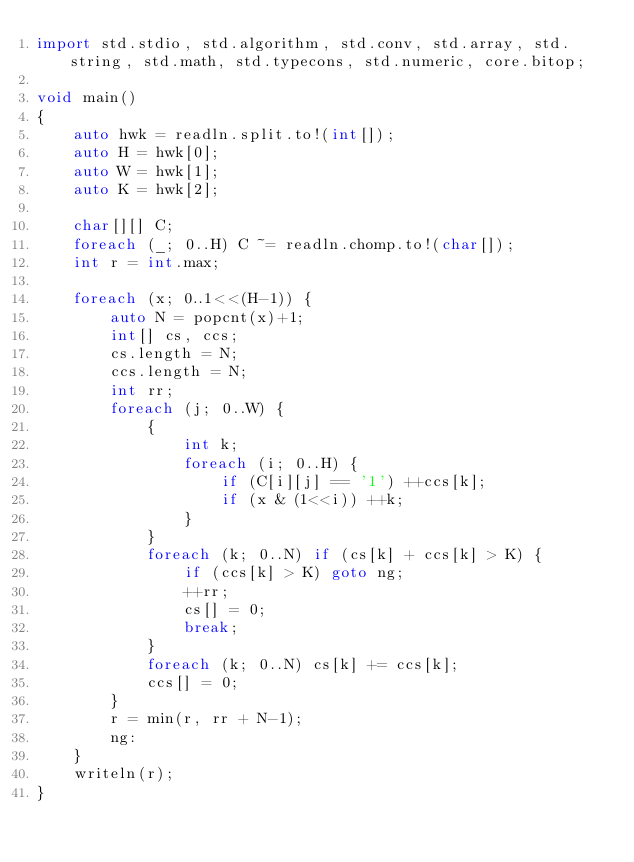Convert code to text. <code><loc_0><loc_0><loc_500><loc_500><_D_>import std.stdio, std.algorithm, std.conv, std.array, std.string, std.math, std.typecons, std.numeric, core.bitop;

void main()
{
    auto hwk = readln.split.to!(int[]);
    auto H = hwk[0];
    auto W = hwk[1];
    auto K = hwk[2];

    char[][] C;
    foreach (_; 0..H) C ~= readln.chomp.to!(char[]);
    int r = int.max;

    foreach (x; 0..1<<(H-1)) {
        auto N = popcnt(x)+1;
        int[] cs, ccs;
        cs.length = N;
        ccs.length = N;
        int rr;
        foreach (j; 0..W) {
            {
                int k;
                foreach (i; 0..H) {
                    if (C[i][j] == '1') ++ccs[k];
                    if (x & (1<<i)) ++k;
                }
            }
            foreach (k; 0..N) if (cs[k] + ccs[k] > K) {
                if (ccs[k] > K) goto ng;
                ++rr;
                cs[] = 0;
                break;
            }
            foreach (k; 0..N) cs[k] += ccs[k];
            ccs[] = 0;
        }
        r = min(r, rr + N-1);
        ng:
    }
    writeln(r);
}</code> 